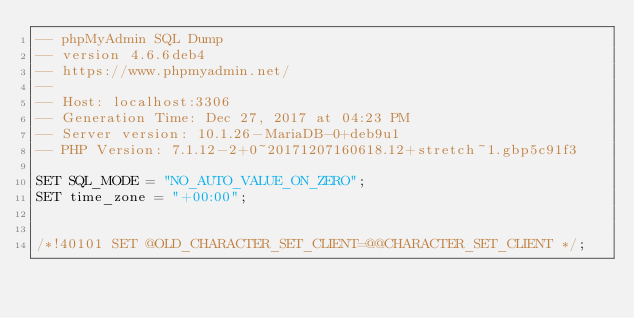<code> <loc_0><loc_0><loc_500><loc_500><_SQL_>-- phpMyAdmin SQL Dump
-- version 4.6.6deb4
-- https://www.phpmyadmin.net/
--
-- Host: localhost:3306
-- Generation Time: Dec 27, 2017 at 04:23 PM
-- Server version: 10.1.26-MariaDB-0+deb9u1
-- PHP Version: 7.1.12-2+0~20171207160618.12+stretch~1.gbp5c91f3

SET SQL_MODE = "NO_AUTO_VALUE_ON_ZERO";
SET time_zone = "+00:00";


/*!40101 SET @OLD_CHARACTER_SET_CLIENT=@@CHARACTER_SET_CLIENT */;</code> 